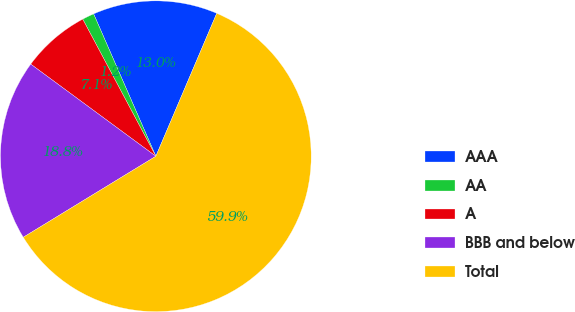Convert chart. <chart><loc_0><loc_0><loc_500><loc_500><pie_chart><fcel>AAA<fcel>AA<fcel>A<fcel>BBB and below<fcel>Total<nl><fcel>12.97%<fcel>1.24%<fcel>7.1%<fcel>18.83%<fcel>59.86%<nl></chart> 